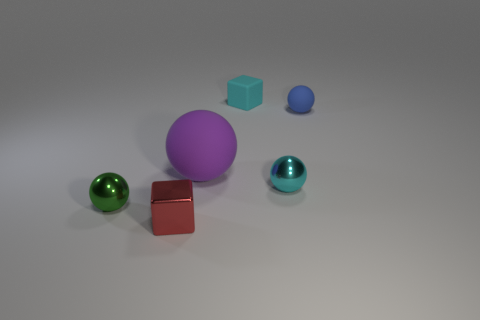Add 3 purple spheres. How many objects exist? 9 Subtract all cyan spheres. How many spheres are left? 3 Subtract all small green spheres. How many spheres are left? 3 Subtract all spheres. How many objects are left? 2 Subtract 1 cubes. How many cubes are left? 1 Subtract all green blocks. Subtract all purple cylinders. How many blocks are left? 2 Subtract all green cubes. How many blue balls are left? 1 Subtract all cyan objects. Subtract all tiny rubber balls. How many objects are left? 3 Add 1 blue objects. How many blue objects are left? 2 Add 2 gray rubber blocks. How many gray rubber blocks exist? 2 